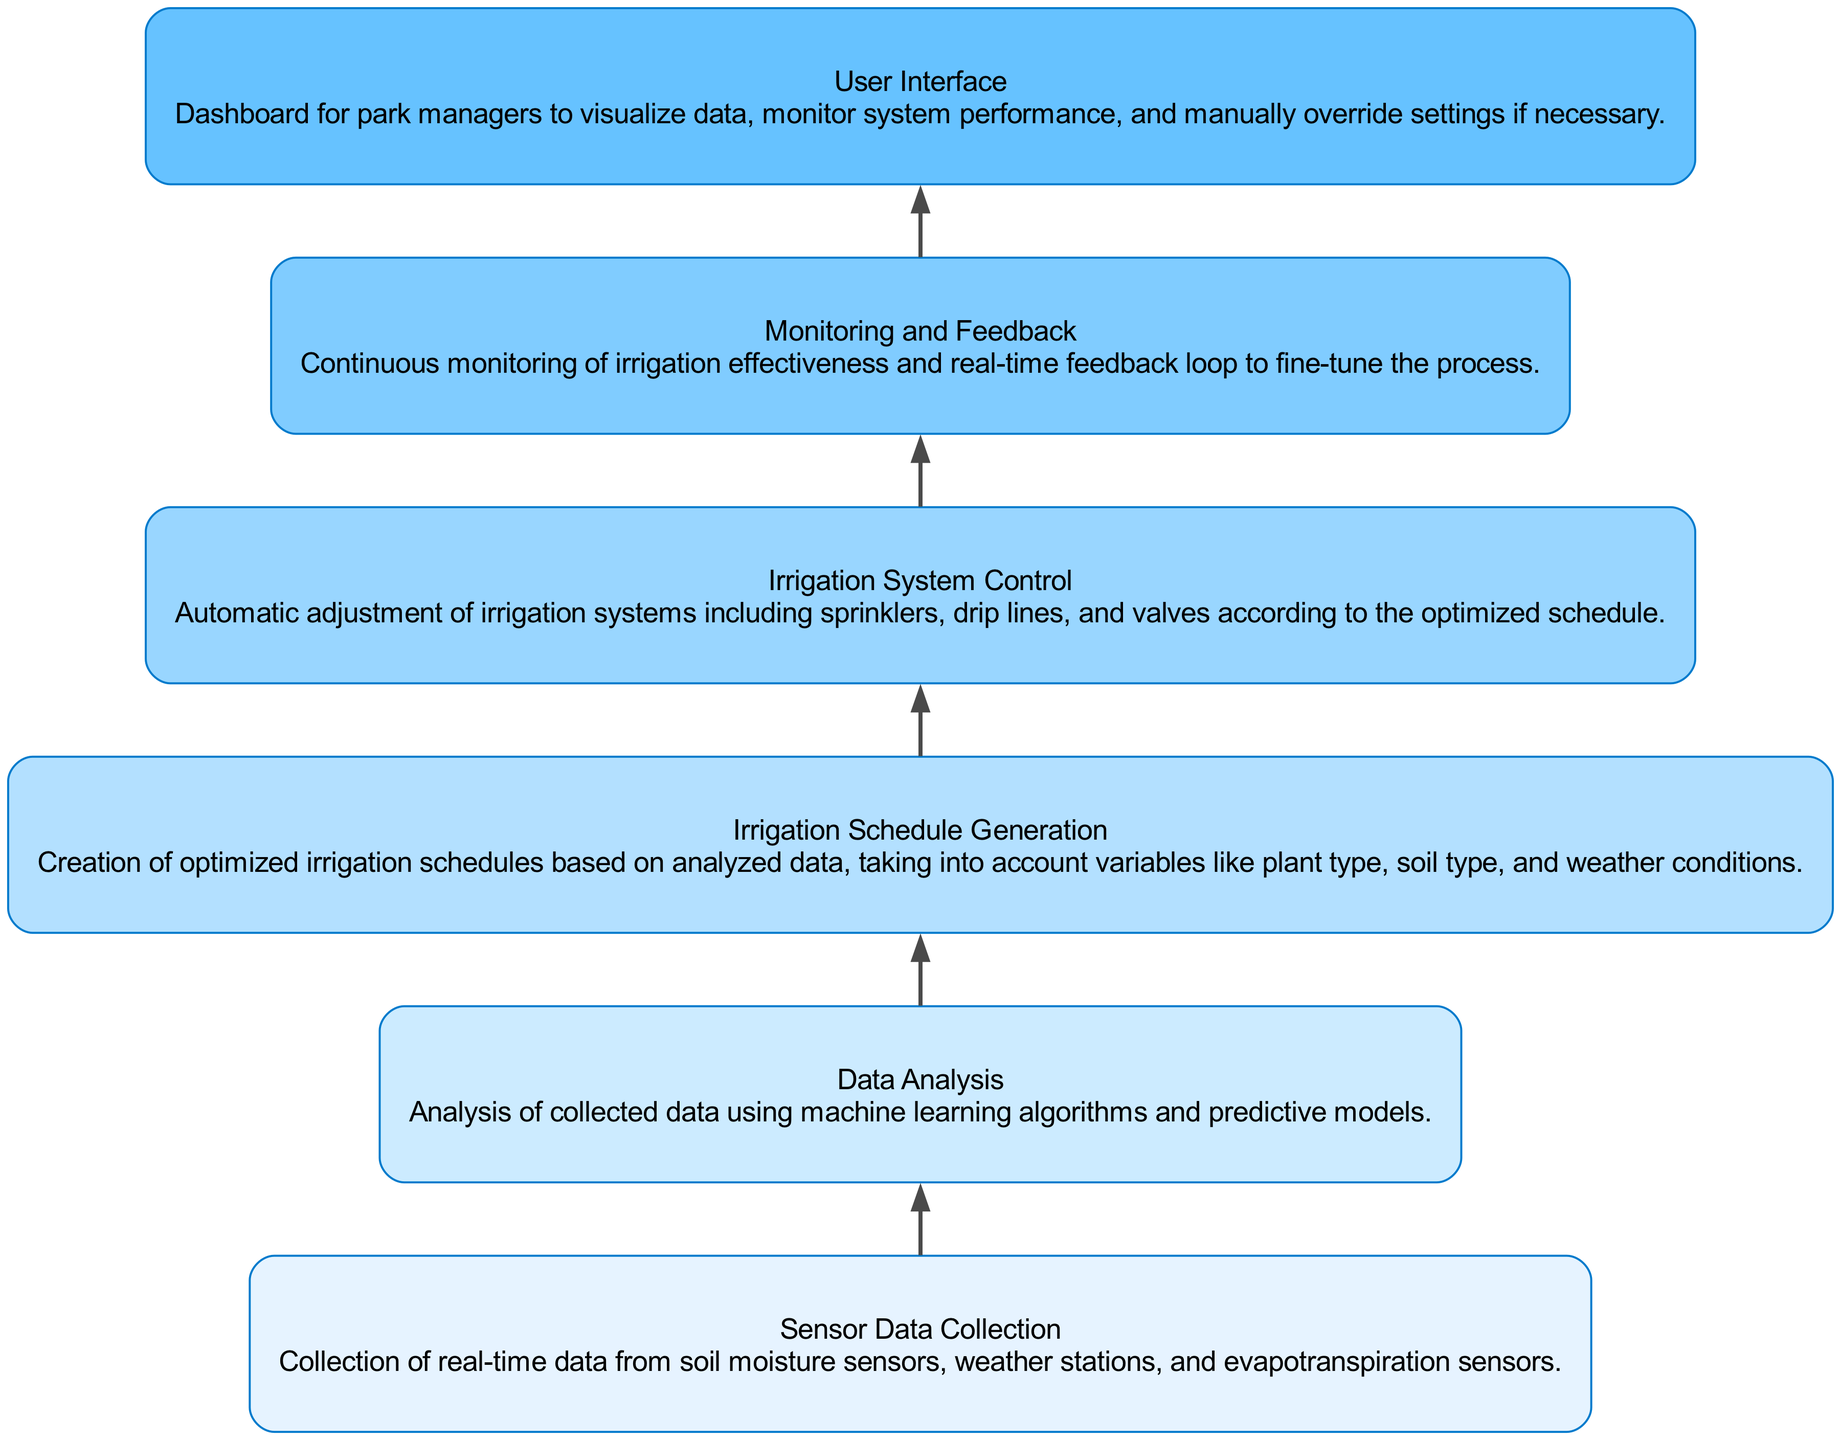What is the first step in the irrigation process? The first step in the irrigation process, as indicated at the bottom of the flow chart, is "Sensor Data Collection," which involves gathering real-time data from various sensors.
Answer: Sensor Data Collection How many elements are there in the flow chart? The flow chart includes six elements, as can be counted from the list presented in the diagram.
Answer: 6 What follows data analysis in the flow sequence? According to the flow order outlined in the chart, "Irrigation Schedule Generation" comes directly after "Data Analysis."
Answer: Irrigation Schedule Generation Which node involves automatic adjustments? The node that involves automatic adjustments according to the optimized irrigation schedule is "Irrigation System Control," which is clearly labeled in the flow chart.
Answer: Irrigation System Control How does effective monitoring occur in the irrigation process? Continuous monitoring of irrigation effectiveness is achieved through the "Monitoring and Feedback" step, where a feedback loop is established for fine-tuning the irrigation process.
Answer: Monitoring and Feedback Name the user interface's main purpose. The main purpose of the "User Interface" is to provide a dashboard for park managers to visualize data and monitor system performance.
Answer: Visualize data and monitor system performance What is the last step in the flow chart? The last step in the flow chart is the "User Interface," which is positioned at the top of the diagram, indicating its role in overseeing the entire process.
Answer: User Interface Which element is paired with machine learning algorithms? "Data Analysis" is the element paired with machine learning algorithms, as it describes the process of analyzing real-time sensor data using such algorithms.
Answer: Data Analysis What's the relationship between irrigation schedule generation and system control? "Irrigation Schedule Generation" directly feeds into "Irrigation System Control," indicating that the generation of schedules informs how the irrigation system is automatically adjusted.
Answer: Directly connected 